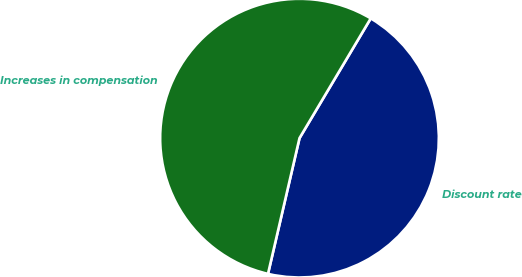<chart> <loc_0><loc_0><loc_500><loc_500><pie_chart><fcel>Discount rate<fcel>Increases in compensation<nl><fcel>45.09%<fcel>54.91%<nl></chart> 